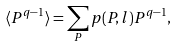Convert formula to latex. <formula><loc_0><loc_0><loc_500><loc_500>\langle P ^ { q - 1 } \rangle = \sum _ { P } p ( P , l ) P ^ { q - 1 } ,</formula> 